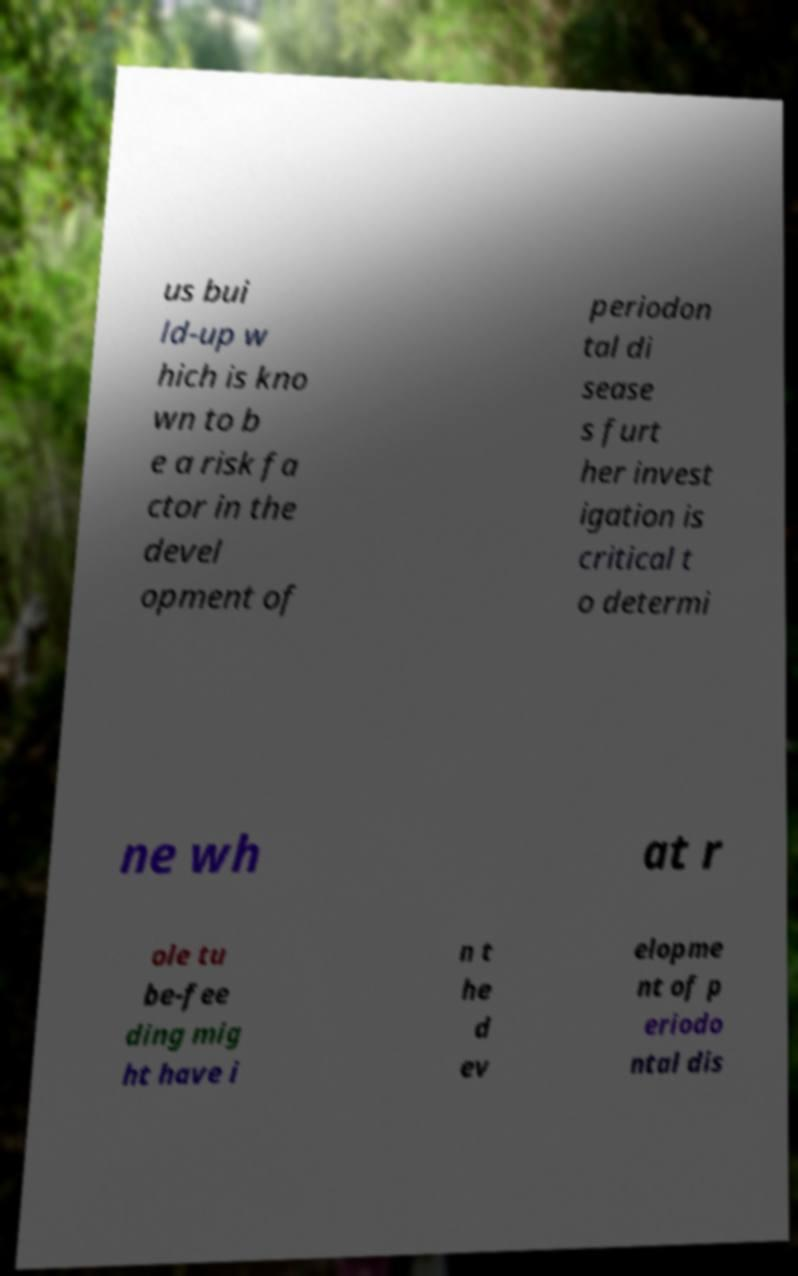What messages or text are displayed in this image? I need them in a readable, typed format. us bui ld-up w hich is kno wn to b e a risk fa ctor in the devel opment of periodon tal di sease s furt her invest igation is critical t o determi ne wh at r ole tu be-fee ding mig ht have i n t he d ev elopme nt of p eriodo ntal dis 